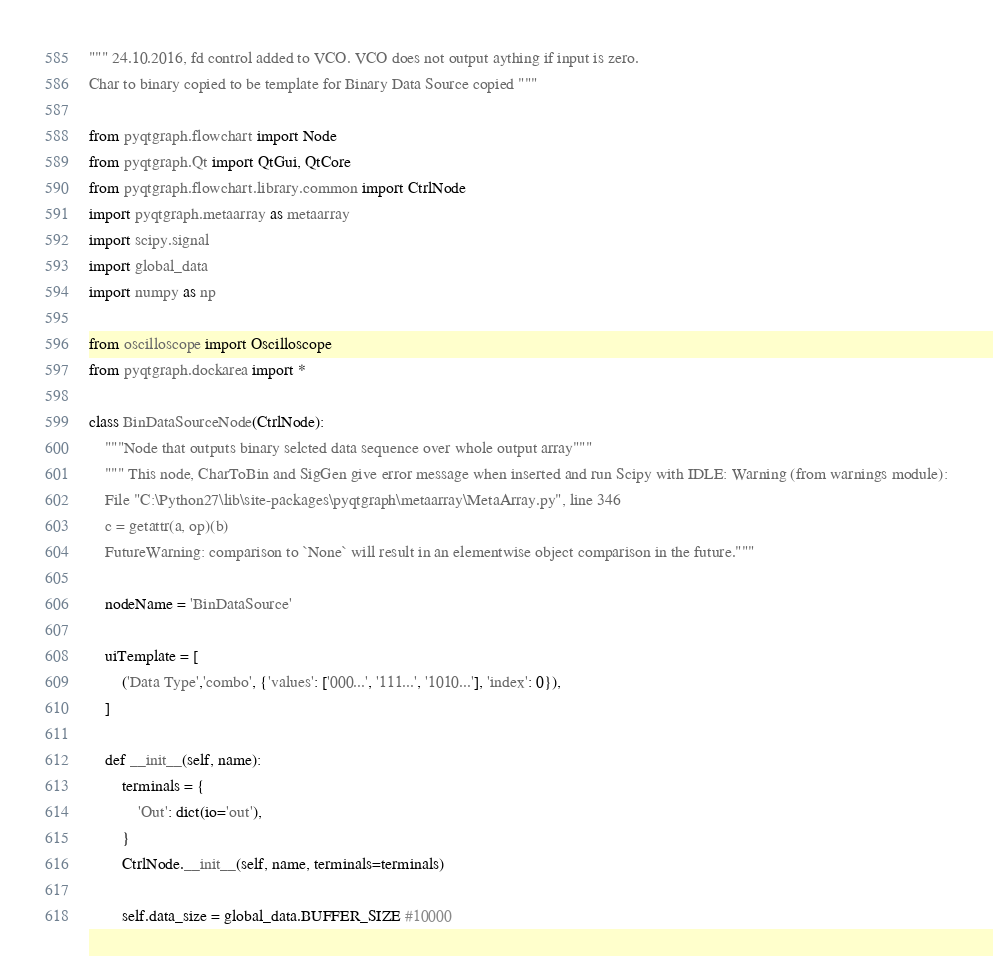<code> <loc_0><loc_0><loc_500><loc_500><_Python_>""" 24.10.2016, fd control added to VCO. VCO does not output aything if input is zero.
Char to binary copied to be template for Binary Data Source copied """

from pyqtgraph.flowchart import Node
from pyqtgraph.Qt import QtGui, QtCore
from pyqtgraph.flowchart.library.common import CtrlNode
import pyqtgraph.metaarray as metaarray
import scipy.signal
import global_data
import numpy as np

from oscilloscope import Oscilloscope
from pyqtgraph.dockarea import *

class BinDataSourceNode(CtrlNode):
    """Node that outputs binary selcted data sequence over whole output array"""
    """ This node, CharToBin and SigGen give error message when inserted and run Scipy with IDLE: Warning (from warnings module):
    File "C:\Python27\lib\site-packages\pyqtgraph\metaarray\MetaArray.py", line 346
    c = getattr(a, op)(b)
    FutureWarning: comparison to `None` will result in an elementwise object comparison in the future."""
    
    nodeName = 'BinDataSource'

    uiTemplate = [
        ('Data Type','combo', {'values': ['000...', '111...', '1010...'], 'index': 0}),
    ]

    def __init__(self, name):
        terminals = {
            'Out': dict(io='out'),
        }
        CtrlNode.__init__(self, name, terminals=terminals)

        self.data_size = global_data.BUFFER_SIZE #10000</code> 